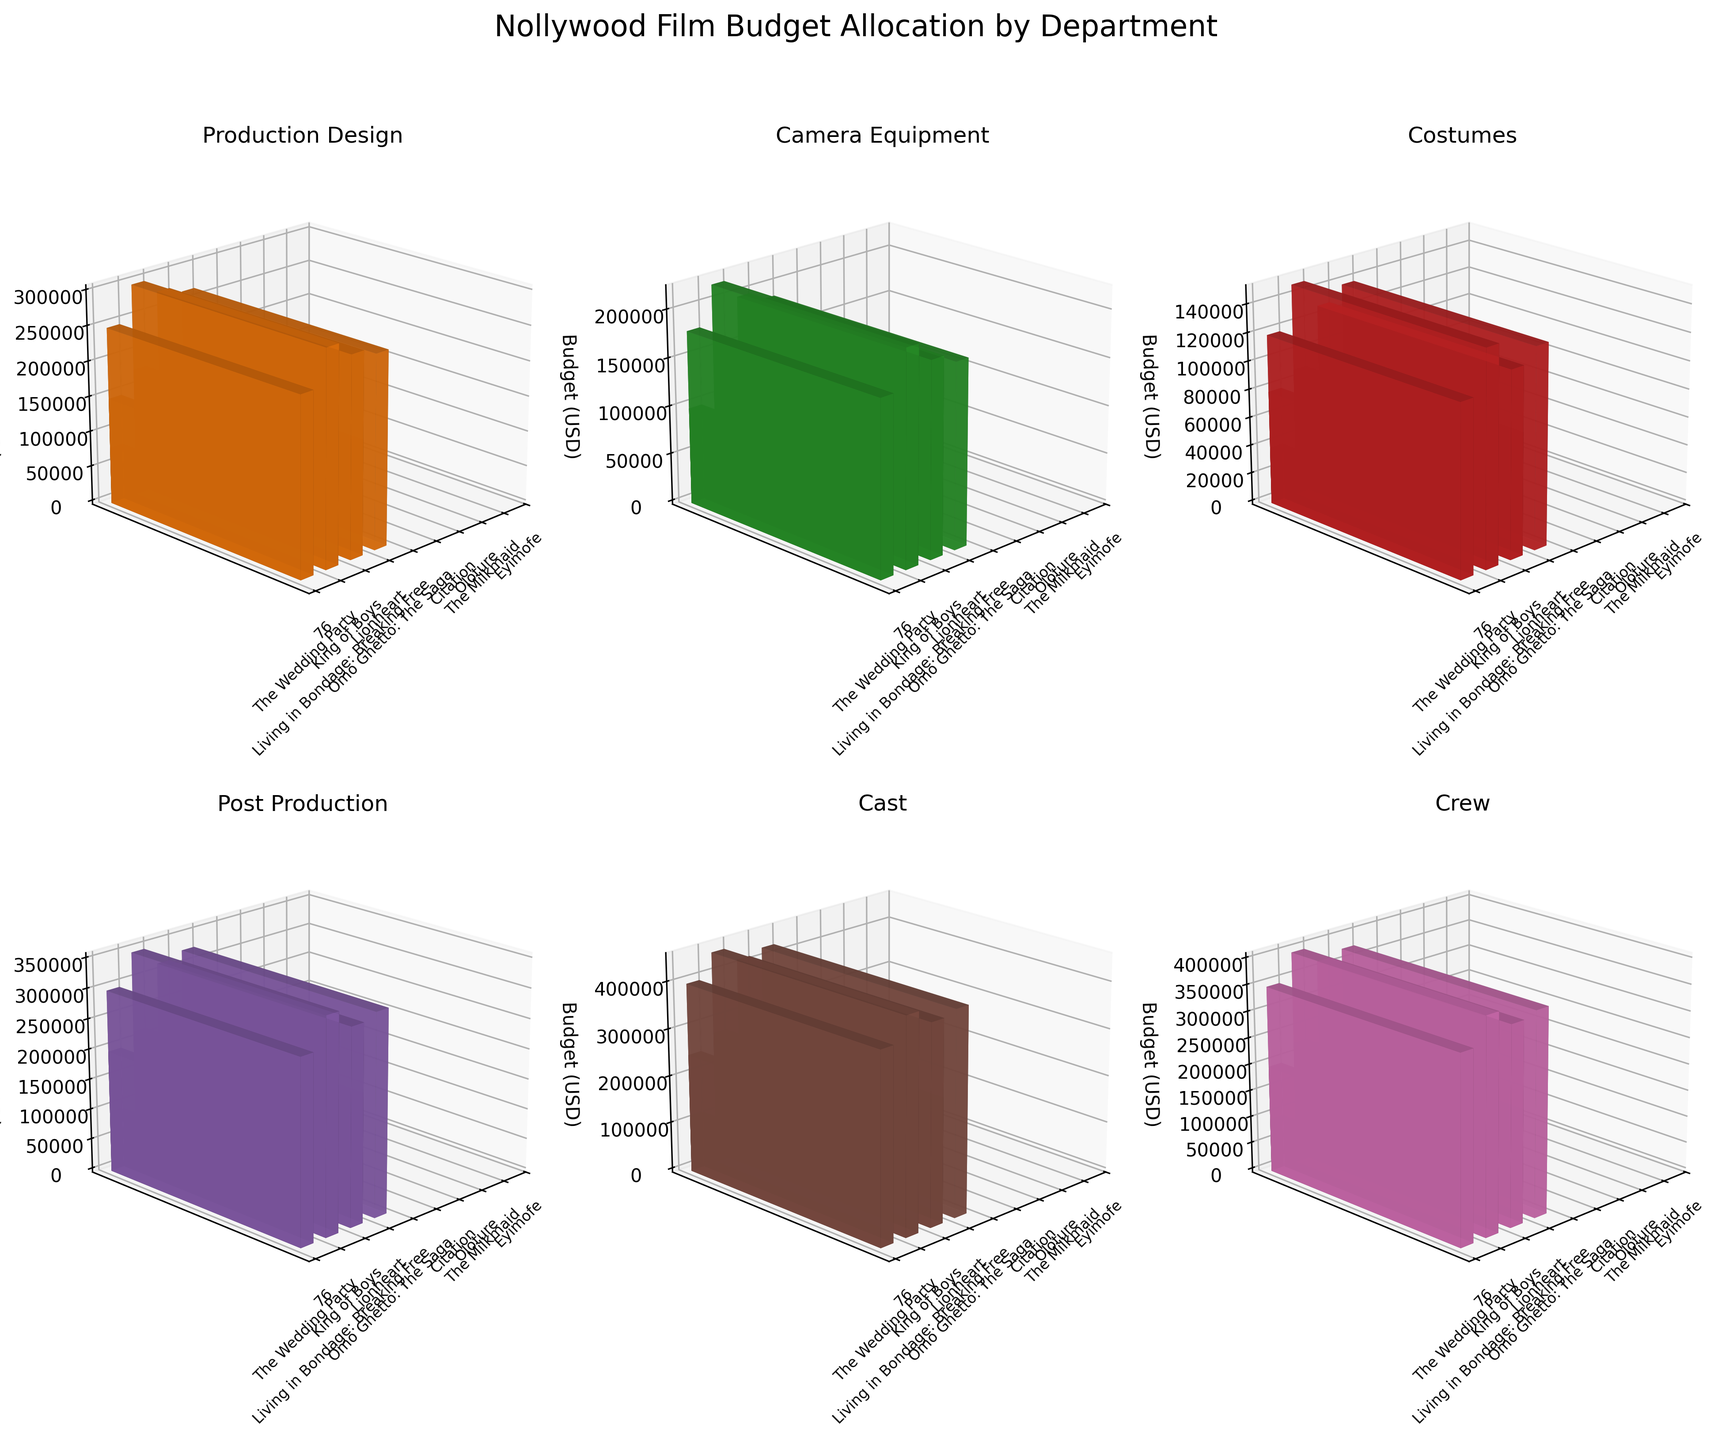What is the total budget allocated for Production Design in high-budget films? To find this, sum the values for the Production Design department in high-budget films. The high-budget films are "76", "King of Boys", "Living in Bondage: Breaking Free", and "Omo Ghetto: The Saga". Adding 250000 + 300000 + 280000 + 270000 = 1100000
Answer: 1100000 Which department has the highest budget allocation in the film "Lionheart"? To determine this, refer to the segment dedicated to "Lionheart" and compare the budget values across different departments. For "Lionheart", the budgets are: Production Design - 180000, Camera Equipment - 120000, Costumes - 90000, Post Production - 220000, Cast - 280000, Crew - 230000. The Cast department has the highest budget allocation at 280000.
Answer: Cast How does the budget for Camera Equipment in medium-budget films compare across different movies? List out the Camera Equipment budget for medium-budget films and compare them: "The Wedding Party" has 100000, "Lionheart" has 120000, and "Citation" has 110000. The budget allocations are quite close: 100000, 120000, and 110000 respectively.
Answer: 100000, 120000, 110000 In which budget scale do you see the highest average budget allocation for the Crew department? Calculate the average for the Crew budget across each budget scale. 
For high-budget: (350000 + 400000 + 370000 + 380000) / 4 = 375000
For medium-budget: (200000 + 230000 + 210000) / 3 = 213333.33
For low-budget: (100000 + 90000 + 95000) / 3 = 95000
The high-budget scale has the highest average budget allocation for Crew.
Answer: High What is the difference in the Production Design budget between "Oloture" and "Eyimofe"? Look at the Production Design budget for both "Oloture" and "Eyimofe". "Oloture" has 80000 and "Eyimofe" has 75000. The difference is 80000 - 75000 = 5000.
Answer: 5000 